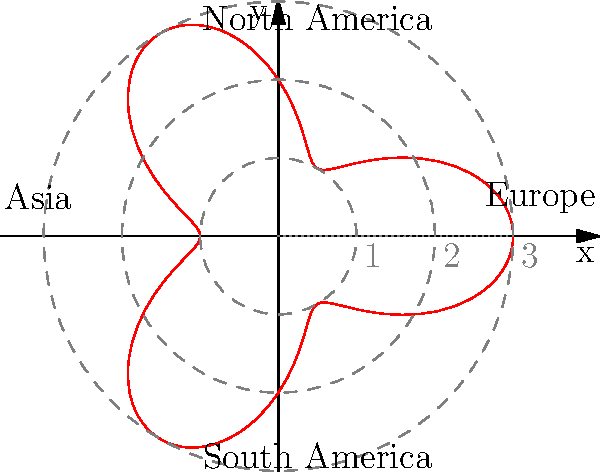Your language learning app has gained global popularity, with user concentrations varying across different regions. The polar graph represents the app's user distribution, where the distance from the center indicates user density, and the angle represents geographical location. If the maximum radius is 3 units, corresponding to 1 million users, approximately how many users does the app have in Asia, represented by the leftmost "petal" of the curve? To solve this problem, we need to follow these steps:

1) Observe that the polar curve is given by $r = 2 + \cos(3\theta)$, where $r$ is the radius and $\theta$ is the angle.

2) Asia is represented by the leftmost "petal" of the curve, which occurs at $\theta = \pi$ (180 degrees).

3) Calculate the radius for Asia:
   $r = 2 + \cos(3\pi) = 2 + (-1) = 1$

4) The maximum radius (3 units) corresponds to 1 million users. We need to set up a proportion:

   $\frac{3 \text{ units}}{1 \text{ million users}} = \frac{1 \text{ unit}}{x \text{ users}}$

5) Cross multiply:
   $3x = 1 \text{ million}$

6) Solve for $x$:
   $x = \frac{1 \text{ million}}{3} \approx 333,333 \text{ users}$

Therefore, the app has approximately 333,333 users in Asia.
Answer: Approximately 333,333 users 